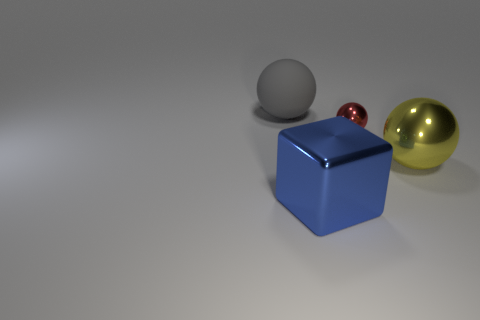Add 1 red metal things. How many objects exist? 5 Subtract all balls. How many objects are left? 1 Add 2 big matte balls. How many big matte balls exist? 3 Subtract 0 yellow blocks. How many objects are left? 4 Subtract all gray matte spheres. Subtract all large gray matte spheres. How many objects are left? 2 Add 3 yellow metal objects. How many yellow metal objects are left? 4 